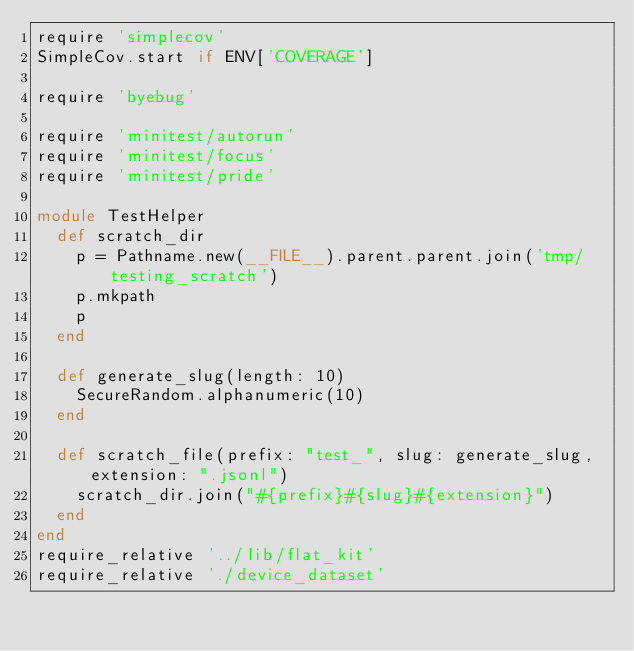Convert code to text. <code><loc_0><loc_0><loc_500><loc_500><_Ruby_>require 'simplecov'
SimpleCov.start if ENV['COVERAGE']

require 'byebug'

require 'minitest/autorun'
require 'minitest/focus'
require 'minitest/pride'

module TestHelper
  def scratch_dir
    p = Pathname.new(__FILE__).parent.parent.join('tmp/testing_scratch')
    p.mkpath
    p
  end

  def generate_slug(length: 10)
    SecureRandom.alphanumeric(10)
  end

  def scratch_file(prefix: "test_", slug: generate_slug, extension: ".jsonl")
    scratch_dir.join("#{prefix}#{slug}#{extension}")
  end
end
require_relative '../lib/flat_kit'
require_relative './device_dataset'
</code> 